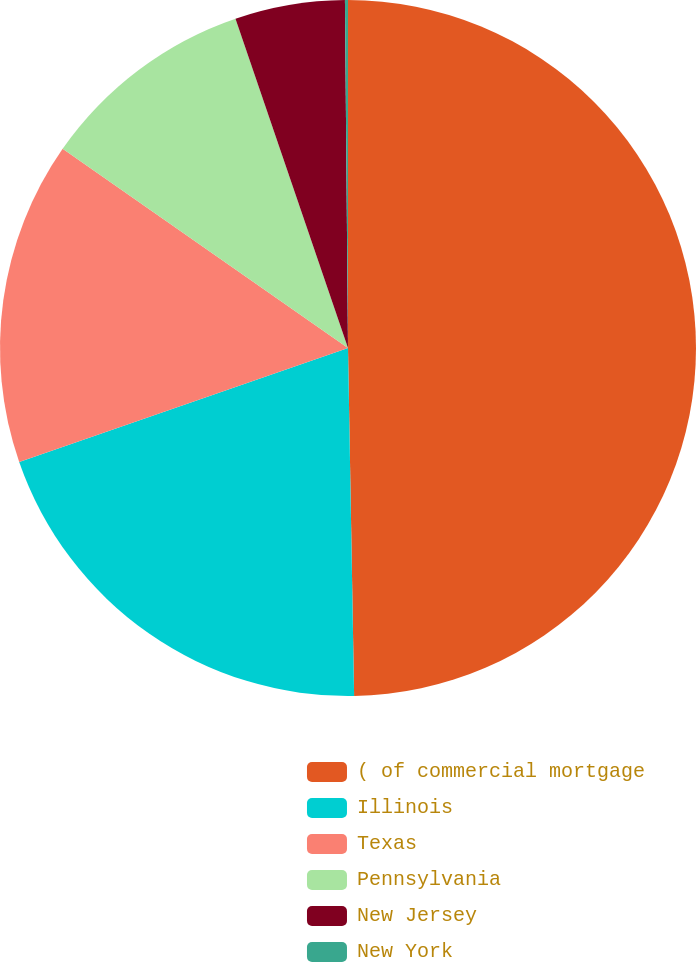Convert chart. <chart><loc_0><loc_0><loc_500><loc_500><pie_chart><fcel>( of commercial mortgage<fcel>Illinois<fcel>Texas<fcel>Pennsylvania<fcel>New Jersey<fcel>New York<nl><fcel>49.72%<fcel>19.97%<fcel>15.01%<fcel>10.06%<fcel>5.1%<fcel>0.14%<nl></chart> 